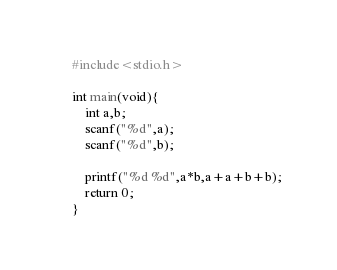Convert code to text. <code><loc_0><loc_0><loc_500><loc_500><_C_>#include<stdio.h>

int main(void){
	int a,b;
	scanf("%d",a);
	scanf("%d",b);
	
	printf("%d %d",a*b,a+a+b+b);
	return 0;
}</code> 